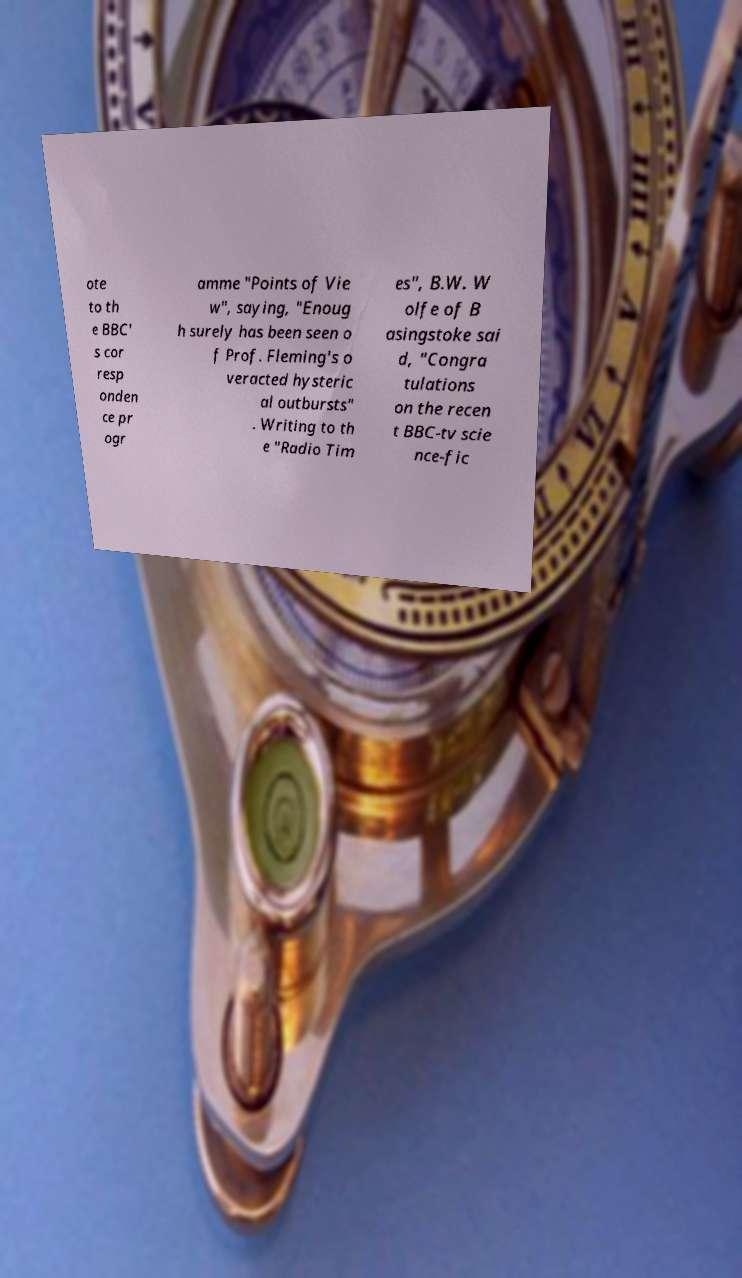Could you extract and type out the text from this image? ote to th e BBC' s cor resp onden ce pr ogr amme "Points of Vie w", saying, "Enoug h surely has been seen o f Prof. Fleming's o veracted hysteric al outbursts" . Writing to th e "Radio Tim es", B.W. W olfe of B asingstoke sai d, "Congra tulations on the recen t BBC-tv scie nce-fic 